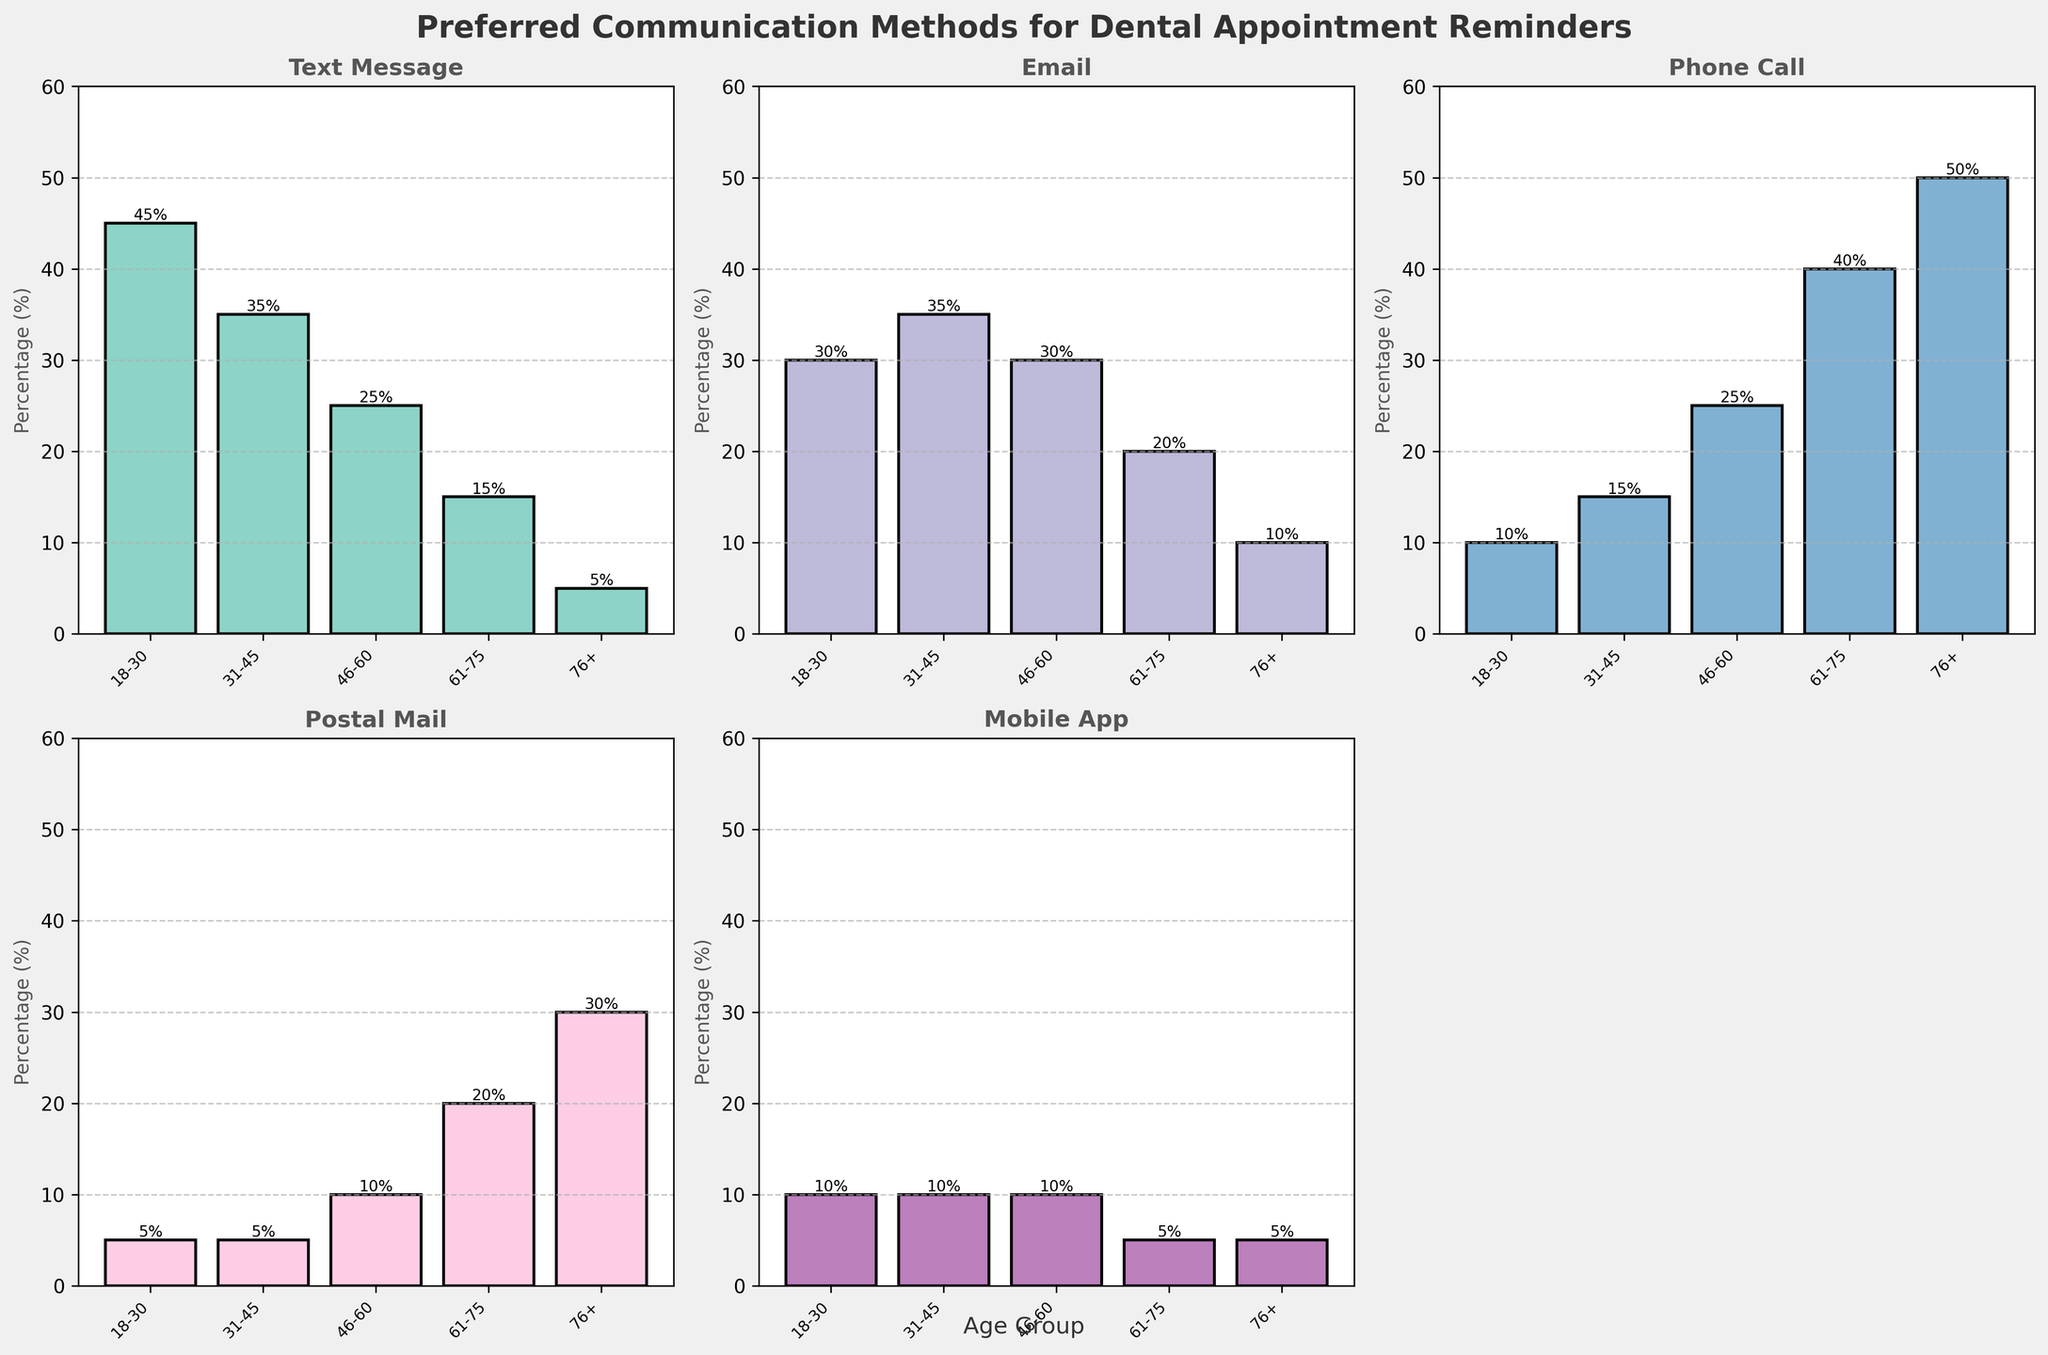What's the most preferred communication method for the 18-30 age group? Looking at the bar for each communication method in the subplot for the 18-30 age group, the highest bar corresponds to Text Message, showing 45%.
Answer: Text Message Which age group prefers postal mail the most? Checking the subplot for Postal Mail, the age group with the highest bar is 76+, showing 30%.
Answer: 76+ What's the combined preference for Text Message and Email in the 31-45 age group? In the subplots for Text Message and Email, the 31-45 age group bars show 35% each. Adding them together: 35% + 35% = 70%.
Answer: 70% How does the preference for Phone Call change with age? Observing the subplot for Phone Call, the height of the bars increases with age: 10% (18-30), 15% (31-45), 25% (46-60), 40% (61-75), and 50% (76+).
Answer: Increases In which age group is the preference for Mobile App highest? Checking the subplot for Mobile App, every age group shows 10% except the 61-75 and 76+ age groups which are 5%. Thus, 10% is the highest and it is shown by 18-30, 31-45, and 46-60 age groups.
Answer: 18-30, 31-45, 46-60 How does the preference for Email compare between age groups 46-60 and 61-75? In the Email subplot, the bar for age group 46-60 is at 30%, while the bar for age group 61-75 is at 20%.
Answer: 46-60 has a higher preference for Email What is the difference in the preference for Phone Call between the 18-30 and 76+ age groups? In the Phone Call subplot, the preference for 18-30 is 10% and for 76+ is 50%. The difference is 50% - 10% = 40%.
Answer: 40% Which age group has the least preference for Mobile App? In the Mobile App subplot, the 61-75 and 76+ age groups both show a preference of 5%, which is the lowest percentage.
Answer: 61-75, 76+ When comparing Text Message and Email, which method is consistently more preferred across all age groups? Looking at the subplots for Text Message and Email side by side, Text Message has higher bars in every age group compared to Email.
Answer: Text Message 